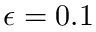<formula> <loc_0><loc_0><loc_500><loc_500>\epsilon = 0 . 1</formula> 